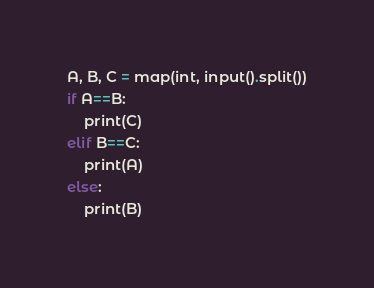<code> <loc_0><loc_0><loc_500><loc_500><_Python_>A, B, C = map(int, input().split())
if A==B:
    print(C)
elif B==C:
    print(A)
else:
    print(B)</code> 